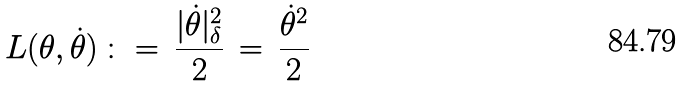Convert formula to latex. <formula><loc_0><loc_0><loc_500><loc_500>L ( \theta , \dot { \theta } ) \, \colon = \, \frac { | \dot { \theta } | _ { \delta } ^ { 2 } } { 2 } \, = \, \frac { \dot { \theta } ^ { 2 } } { 2 }</formula> 